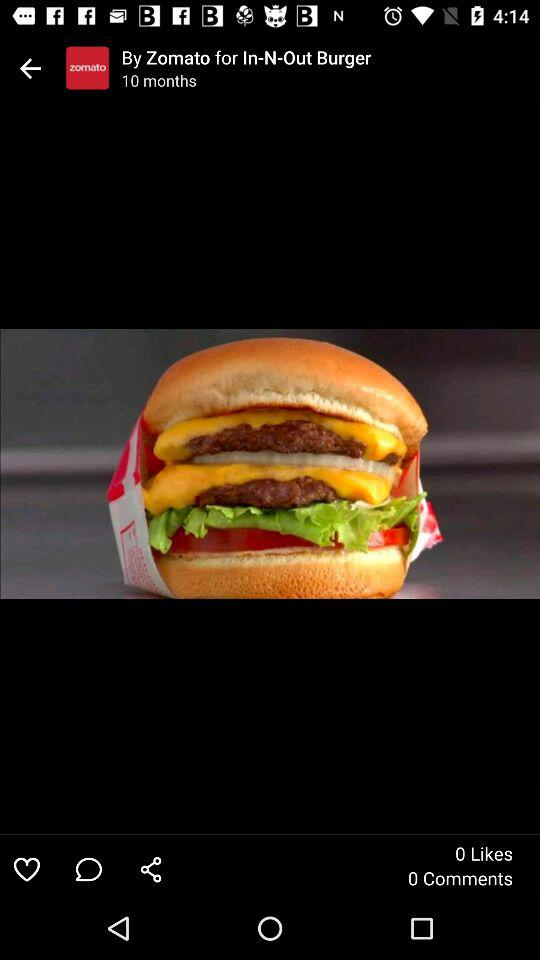When was the picture posted? The picture was posted 10 months ago. 